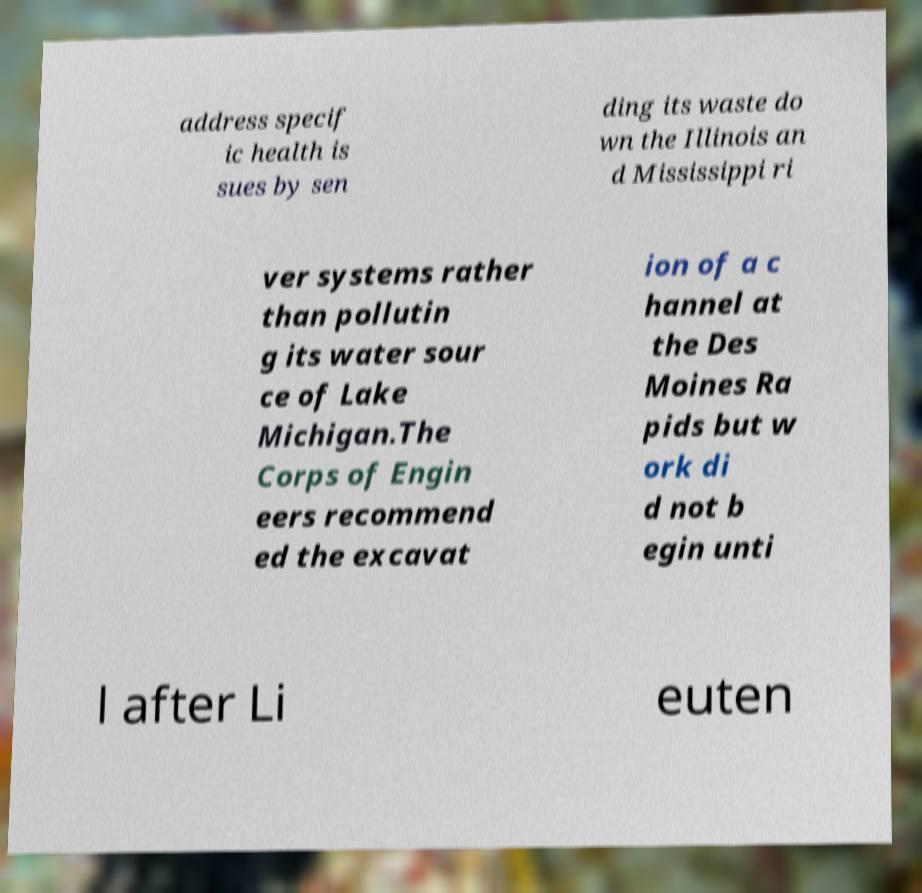I need the written content from this picture converted into text. Can you do that? address specif ic health is sues by sen ding its waste do wn the Illinois an d Mississippi ri ver systems rather than pollutin g its water sour ce of Lake Michigan.The Corps of Engin eers recommend ed the excavat ion of a c hannel at the Des Moines Ra pids but w ork di d not b egin unti l after Li euten 